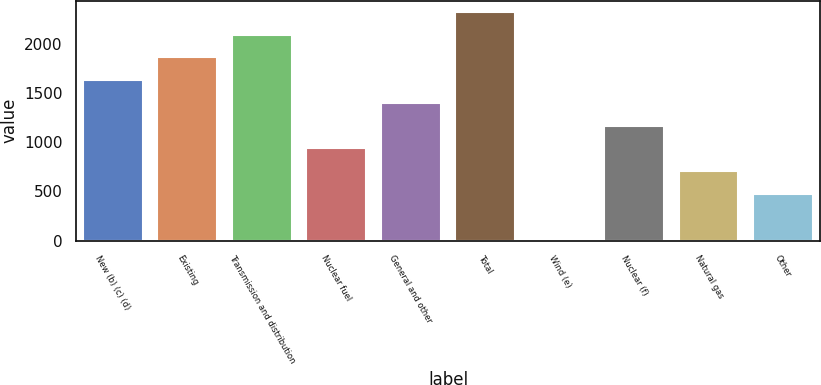Convert chart to OTSL. <chart><loc_0><loc_0><loc_500><loc_500><bar_chart><fcel>New (b) (c) (d)<fcel>Existing<fcel>Transmission and distribution<fcel>Nuclear fuel<fcel>General and other<fcel>Total<fcel>Wind (e)<fcel>Nuclear (f)<fcel>Natural gas<fcel>Other<nl><fcel>1628.5<fcel>1859<fcel>2089.5<fcel>937<fcel>1398<fcel>2320<fcel>15<fcel>1167.5<fcel>706.5<fcel>476<nl></chart> 